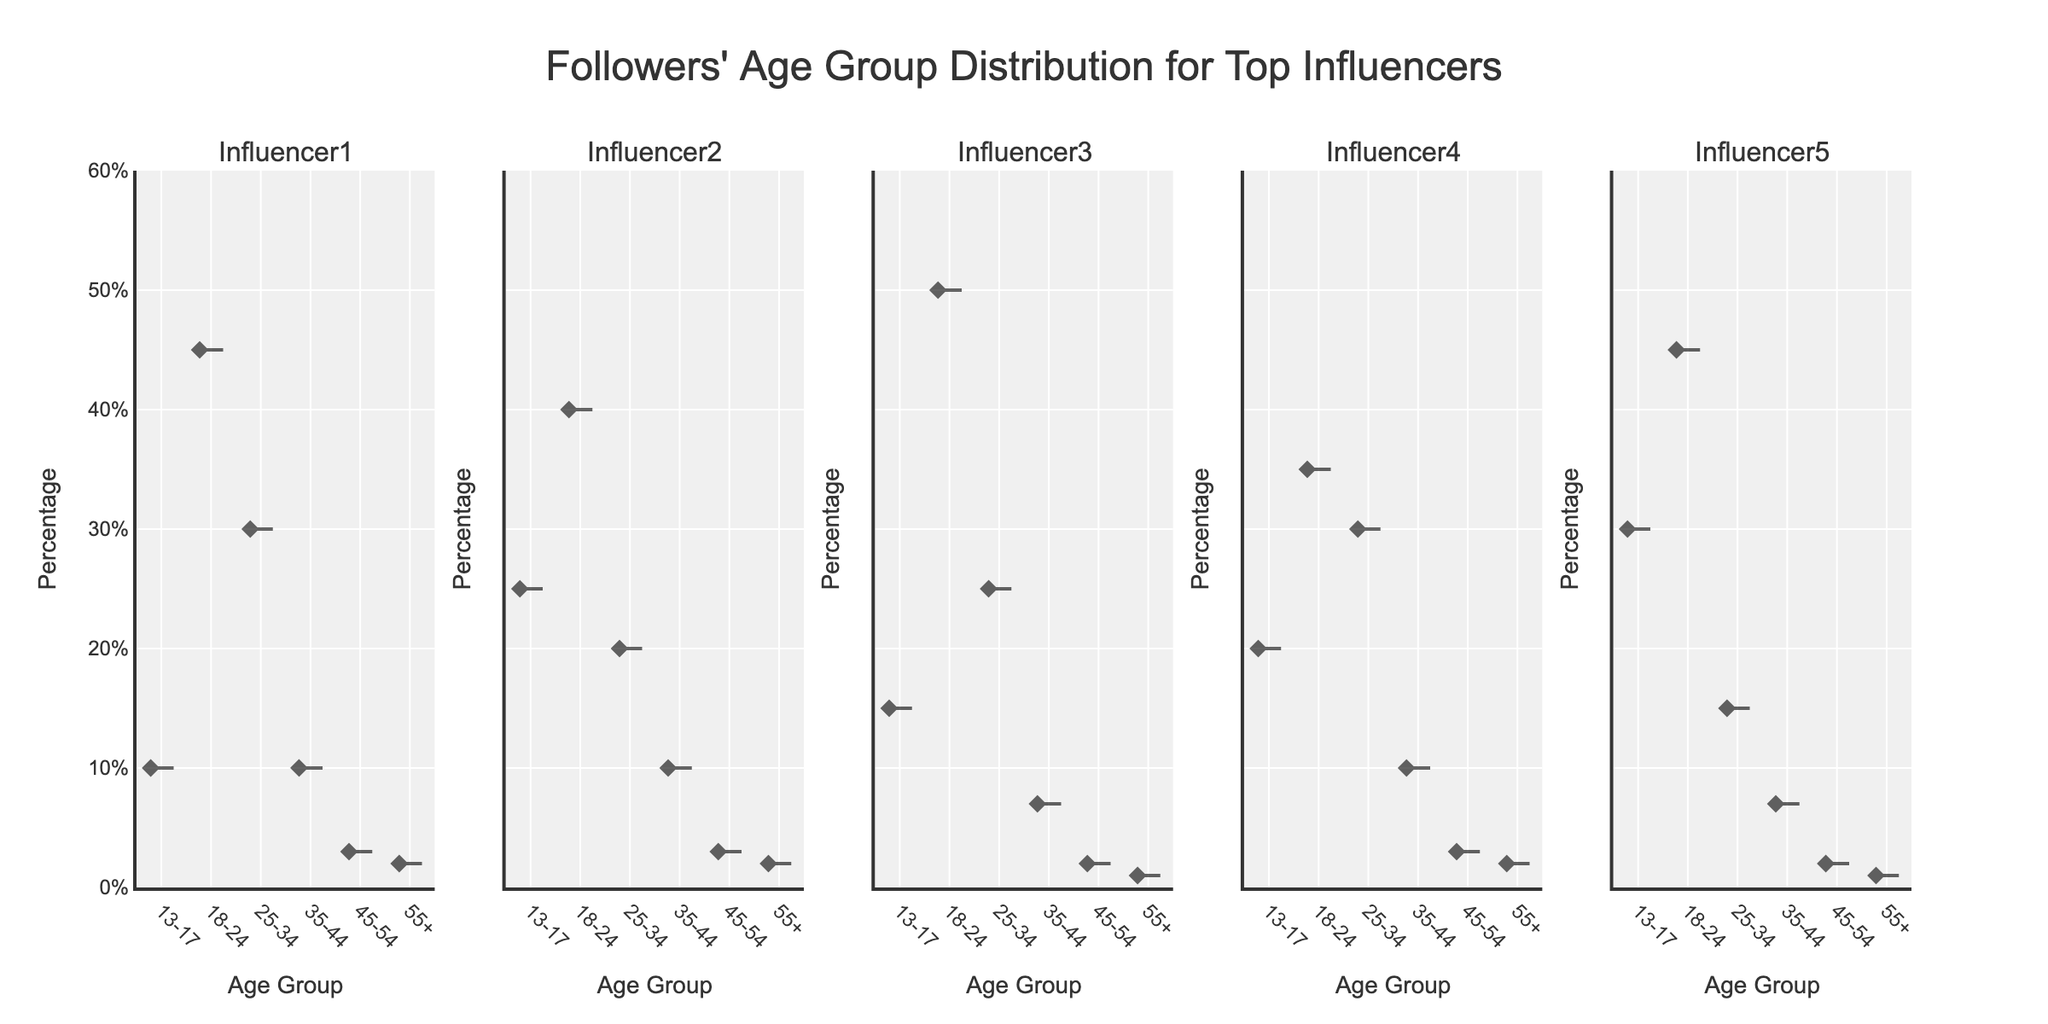What is the title of the figure? The title is displayed at the top center of the figure in a larger font size and says, "Followers' Age Group Distribution for Top Influencers"
Answer: Followers' Age Group Distribution for Top Influencers Which influencer has the highest percentage of followers in the 18-24 age group? By examining each subplot, Influencer3 has the highest percentage in the 18-24 age group, which is indicated around 50%
Answer: Influencer3 Compare the percentage of followers aged 13-17 for Influencer1 and Influencer5. Who has more, and by how much? Influencer1 and Influencer5's violin plots show that Influencer5 has 30% of followers aged 13-17, while Influencer1 has 10%. The difference is 30% - 10% = 20%
Answer: Influencer5, by 20% What is the range of the y-axis in all subplots? The y-axis range is consistent across all subplots, which is indicated by the axis limits and is from 0% to 60%
Answer: 0% to 60% In which age group does Influencer2 have the least percentage of followers? By analyzing the violin plot for Influencer2, the age group with the least percentage is 55+, indicated by around 2%
Answer: 55+ What is the median percentage of followers aged 25-34 for Influencer4? The median line in Influencer4's violin plot for the 25-34 age group appears at 30%
Answer: 30% Compare the age group distribution of Influencer1 and Influencer3. Which influencer has a more evenly spread percentage among the age groups? Influencer1's distribution reveals higher concentration in 18-24 and 25-34 age groups, while Influencer3 has a more pronounced peak in the 18-24 age group with other groups having lower percentages, indicating that Influencer1 has a more evenly distributed percentage among the age groups
Answer: Influencer1 Which influencer has the most diverse age group distribution? A diverse age group distribution typically shows less concentration in specific age groups. Examining the plots, Influencer2 has a relatively balanced distribution across age groups compared to others
Answer: Influencer2 In the 35-44 age group, which influencer has the highest percentage of followers? By looking at each plot, Influencer1, Influencer2, Influencer3, Influencer4 have around 10% each, and Influencer5 has around 7%. Thus, Influencer1, Influencer2, Influencer4 share the highest percentage of 35-44 age group followers
Answer: Influencer1, Influencer2, Influencer4 